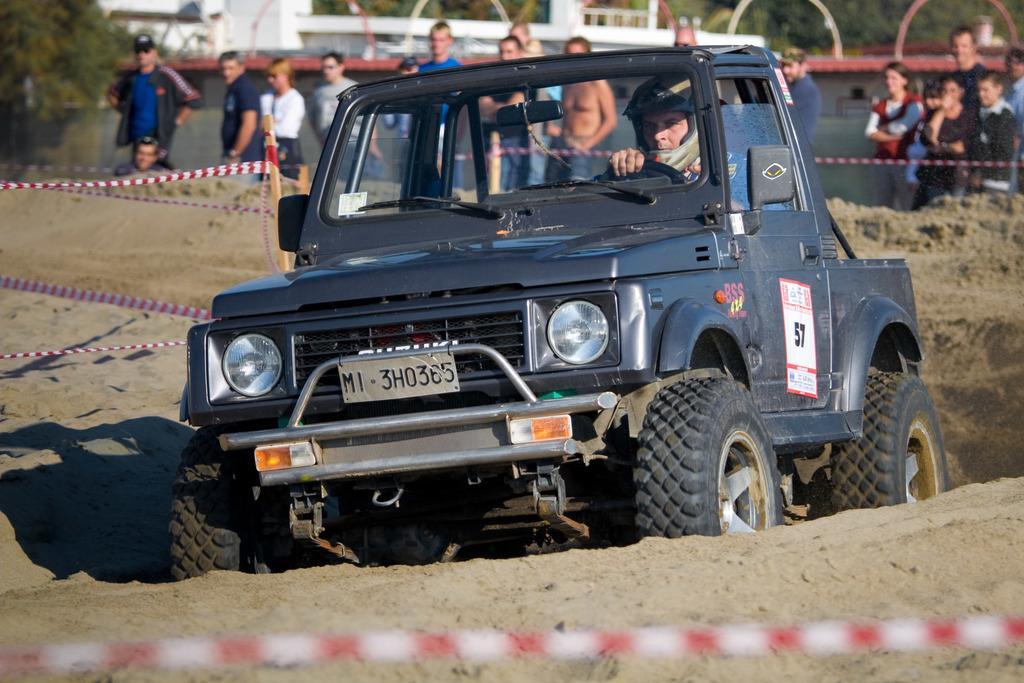Describe this image in one or two sentences. In this picture there is a jeep in the center of the image and there are people at the top side of the image, there are trees in the top left side of the image. 